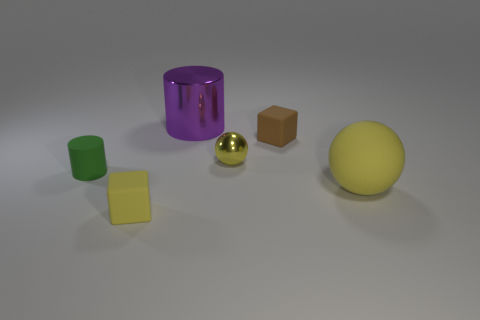Add 4 tiny gray shiny objects. How many objects exist? 10 Subtract all balls. How many objects are left? 4 Add 5 large yellow balls. How many large yellow balls exist? 6 Subtract 0 green cubes. How many objects are left? 6 Subtract all large purple cylinders. Subtract all big spheres. How many objects are left? 4 Add 1 small objects. How many small objects are left? 5 